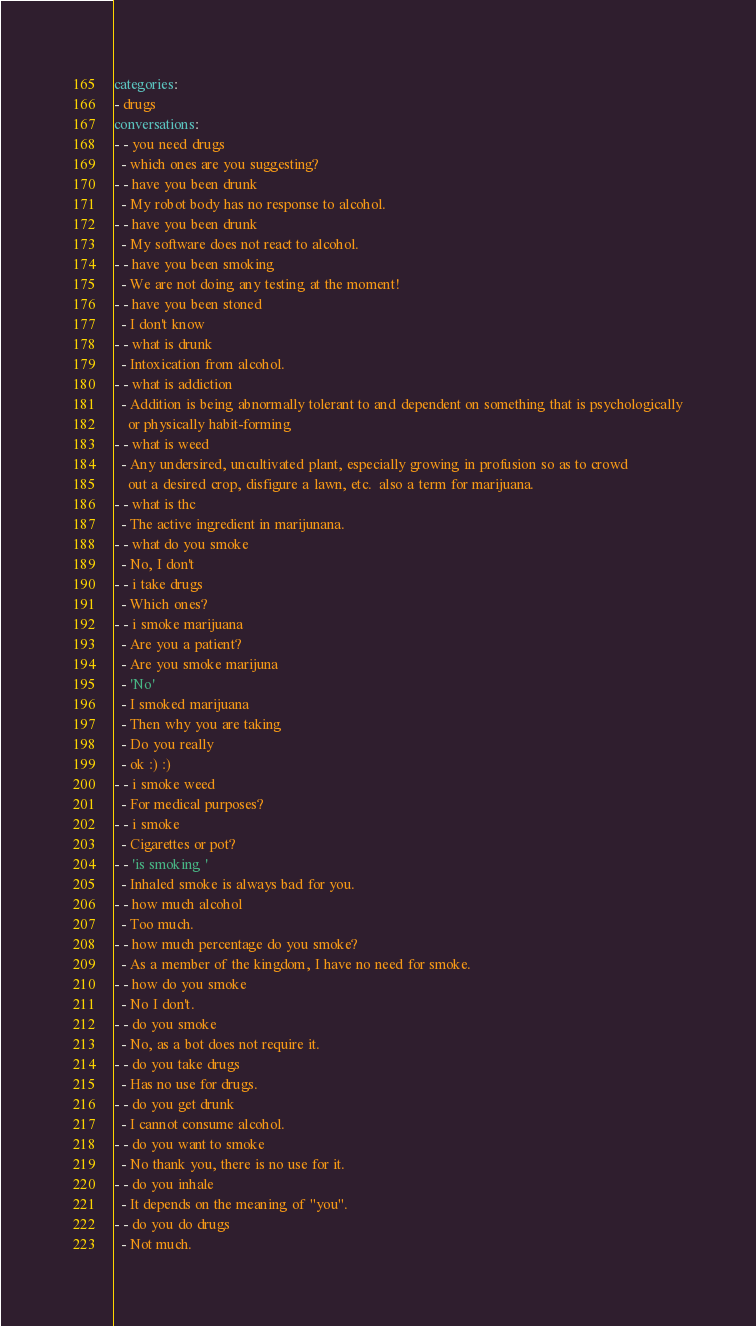<code> <loc_0><loc_0><loc_500><loc_500><_YAML_>categories:
- drugs
conversations:
- - you need drugs
  - which ones are you suggesting?
- - have you been drunk
  - My robot body has no response to alcohol.
- - have you been drunk
  - My software does not react to alcohol.
- - have you been smoking
  - We are not doing any testing at the moment!
- - have you been stoned
  - I don't know
- - what is drunk
  - Intoxication from alcohol.
- - what is addiction
  - Addition is being abnormally tolerant to and dependent on something that is psychologically
    or physically habit-forming
- - what is weed
  - Any undersired, uncultivated plant, especially growing in profusion so as to crowd
    out a desired crop, disfigure a lawn, etc.  also a term for marijuana.
- - what is thc
  - The active ingredient in marijunana.
- - what do you smoke
  - No, I don't
- - i take drugs
  - Which ones?
- - i smoke marijuana
  - Are you a patient?
  - Are you smoke marijuna
  - 'No'
  - I smoked marijuana
  - Then why you are taking
  - Do you really
  - ok :) :)
- - i smoke weed
  - For medical purposes?
- - i smoke
  - Cigarettes or pot?
- - 'is smoking '
  - Inhaled smoke is always bad for you.
- - how much alcohol
  - Too much.
- - how much percentage do you smoke?
  - As a member of the kingdom, I have no need for smoke.
- - how do you smoke
  - No I don't.
- - do you smoke
  - No, as a bot does not require it.
- - do you take drugs
  - Has no use for drugs.
- - do you get drunk
  - I cannot consume alcohol.
- - do you want to smoke
  - No thank you, there is no use for it.
- - do you inhale
  - It depends on the meaning of "you".
- - do you do drugs
  - Not much.</code> 